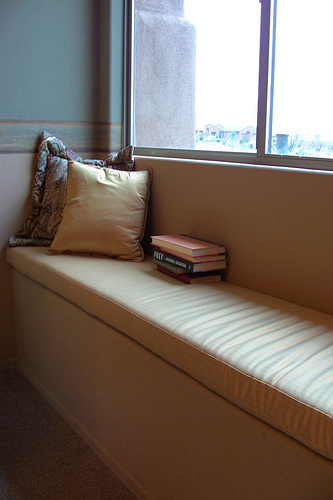<image>
Is the sofa on the books? Yes. Looking at the image, I can see the sofa is positioned on top of the books, with the books providing support. 